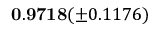Convert formula to latex. <formula><loc_0><loc_0><loc_500><loc_500>0 . 9 7 1 8 ( \pm 0 . 1 1 7 6 )</formula> 